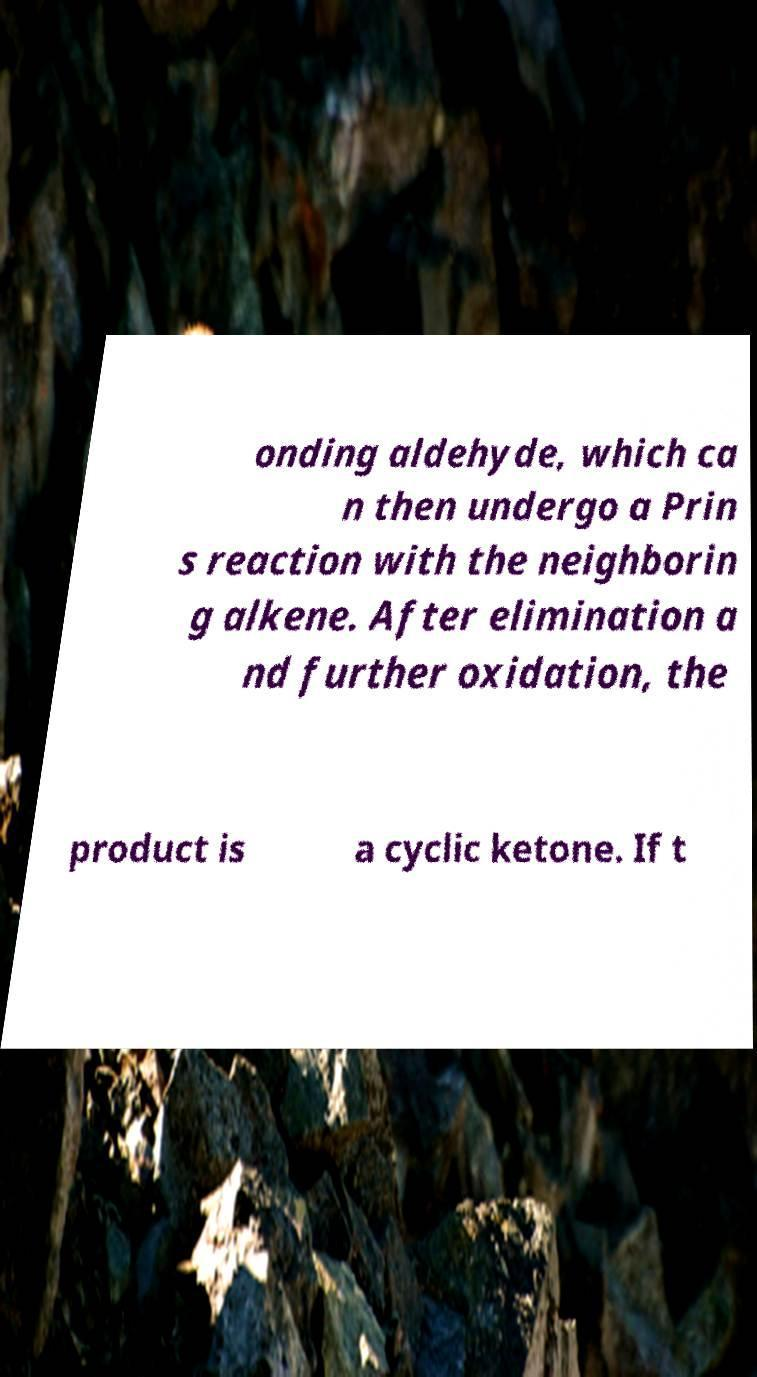Please identify and transcribe the text found in this image. onding aldehyde, which ca n then undergo a Prin s reaction with the neighborin g alkene. After elimination a nd further oxidation, the product is a cyclic ketone. If t 